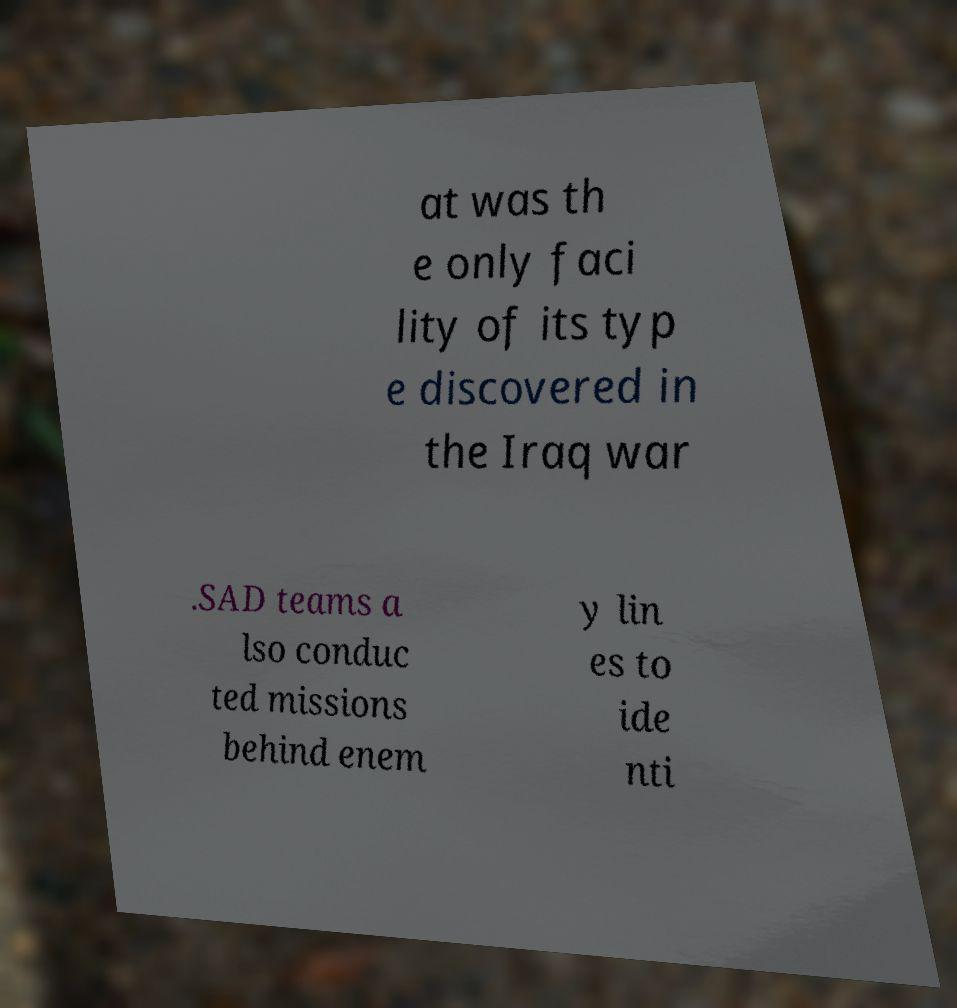Can you read and provide the text displayed in the image?This photo seems to have some interesting text. Can you extract and type it out for me? at was th e only faci lity of its typ e discovered in the Iraq war .SAD teams a lso conduc ted missions behind enem y lin es to ide nti 